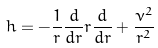<formula> <loc_0><loc_0><loc_500><loc_500>h = - \frac { 1 } { r } \frac { d } { d r } r \frac { d } { d r } + \frac { \nu ^ { 2 } } { r ^ { 2 } }</formula> 